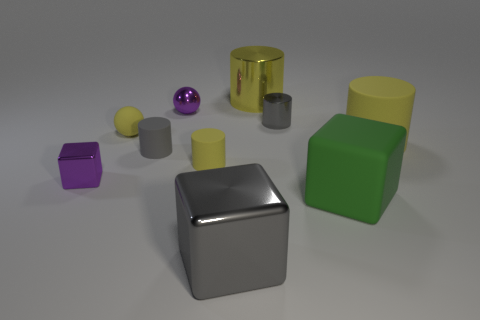Are the tiny cube and the yellow cylinder behind the big yellow matte thing made of the same material?
Provide a short and direct response. Yes. What material is the thing that is the same color as the small metal sphere?
Your response must be concise. Metal. What number of small rubber things are the same color as the small metallic cylinder?
Your response must be concise. 1. The gray matte cylinder has what size?
Provide a succinct answer. Small. Does the tiny gray metal thing have the same shape as the yellow matte thing that is in front of the big yellow rubber cylinder?
Your response must be concise. Yes. What color is the small sphere that is made of the same material as the green cube?
Keep it short and to the point. Yellow. There is a matte cylinder that is on the right side of the green rubber cube; what size is it?
Give a very brief answer. Large. Are there fewer big green things that are behind the gray rubber thing than red shiny cubes?
Your answer should be compact. No. Do the big rubber cube and the tiny shiny ball have the same color?
Your response must be concise. No. Is there anything else that is the same shape as the big gray object?
Your answer should be very brief. Yes. 